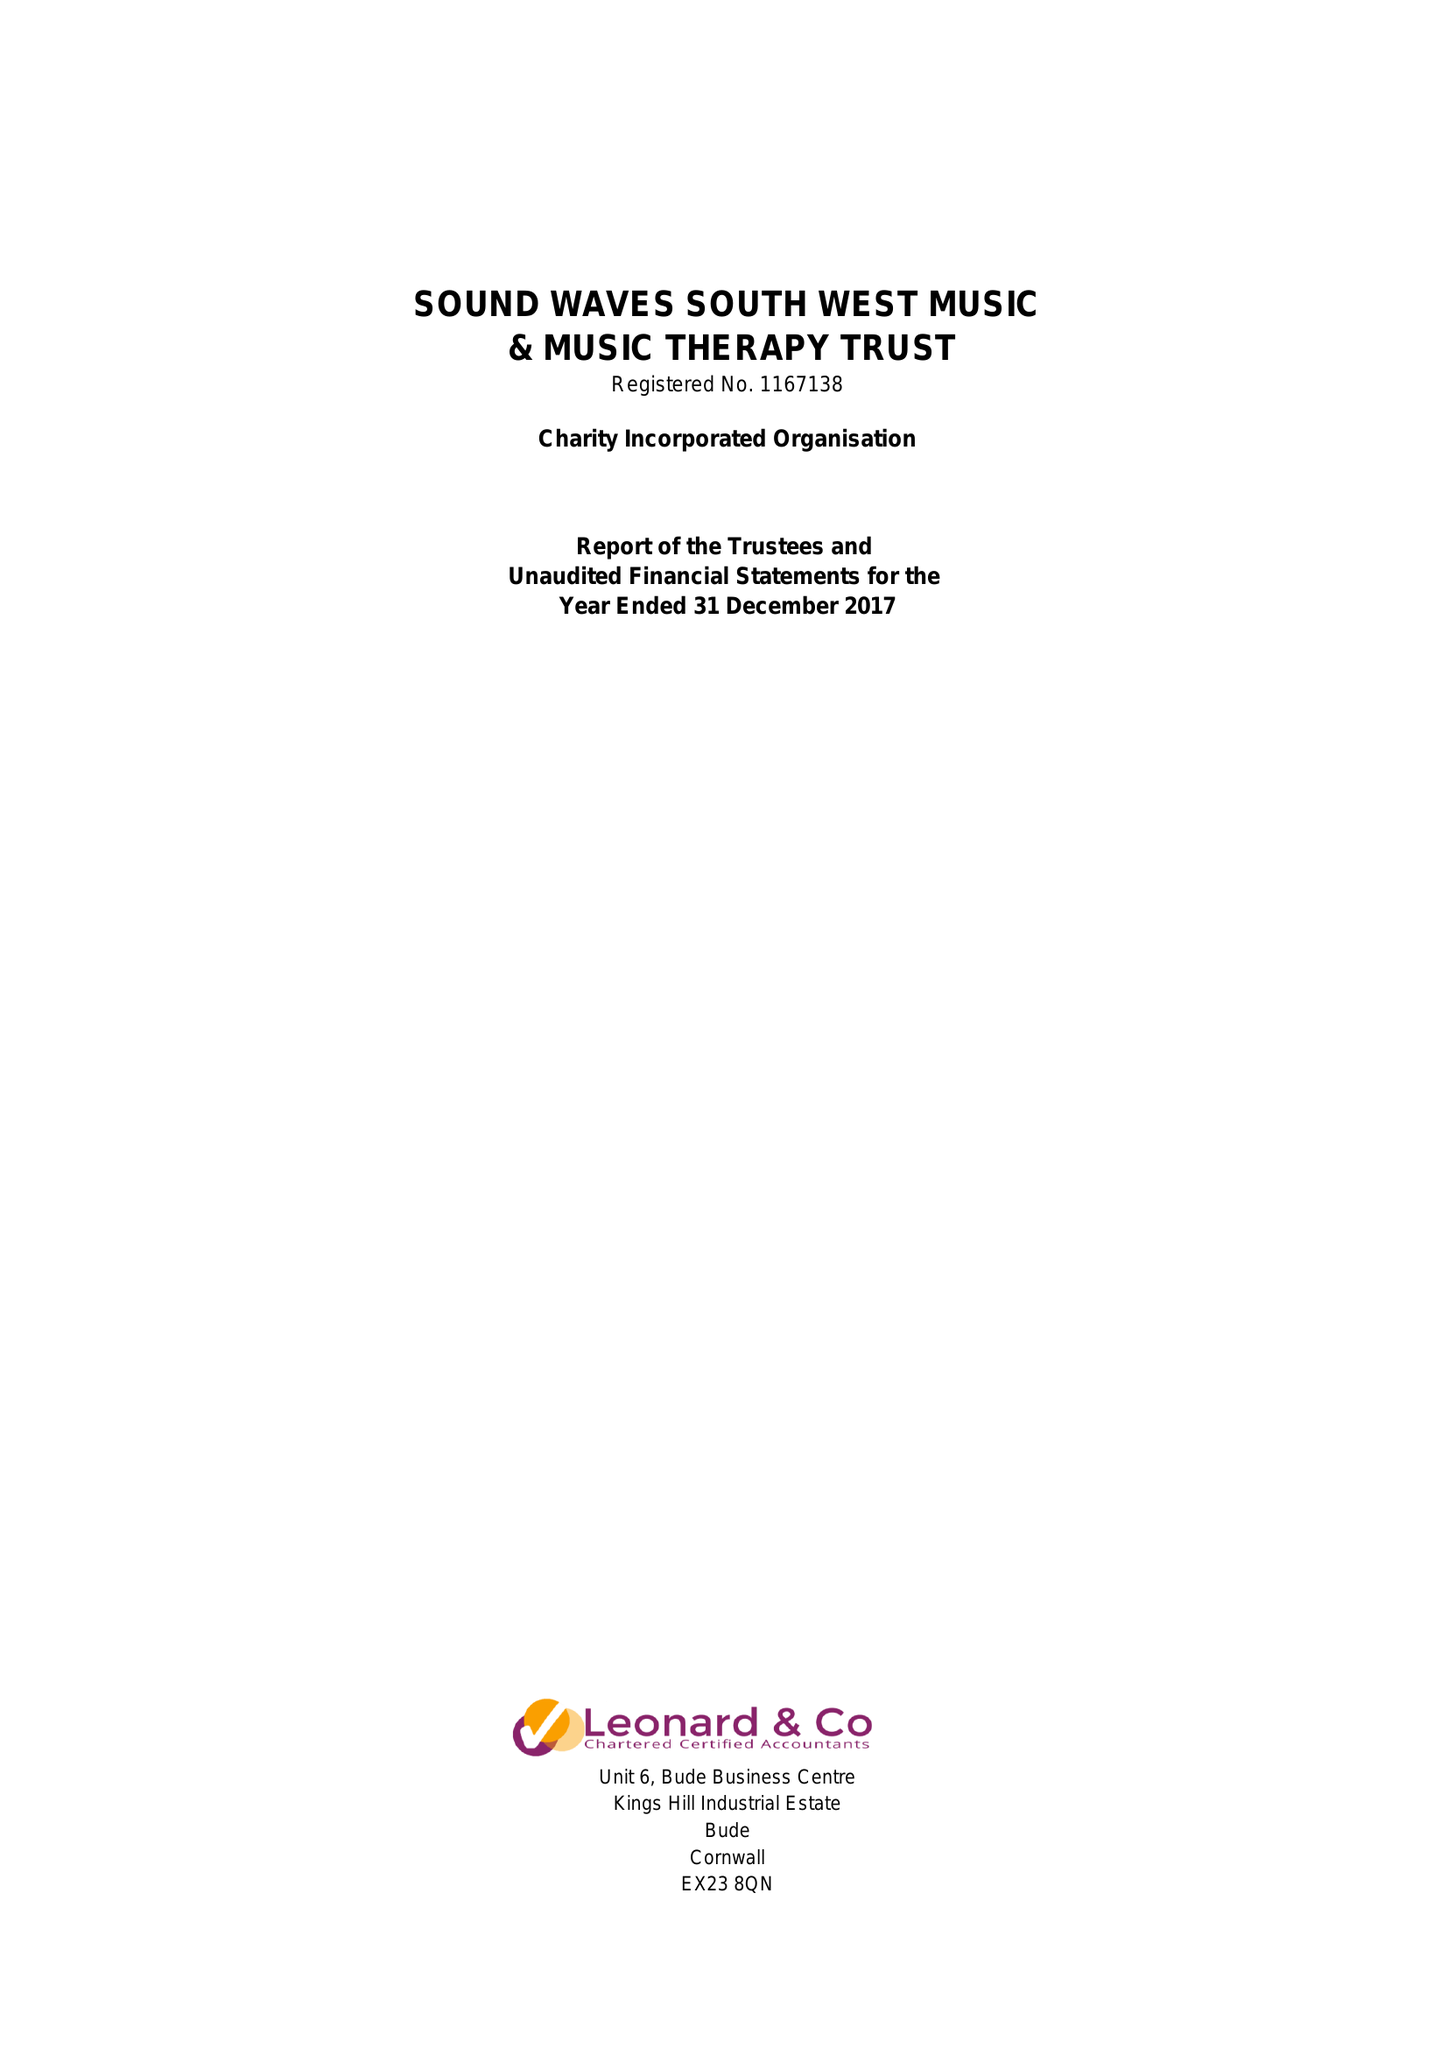What is the value for the income_annually_in_british_pounds?
Answer the question using a single word or phrase. 35767.00 